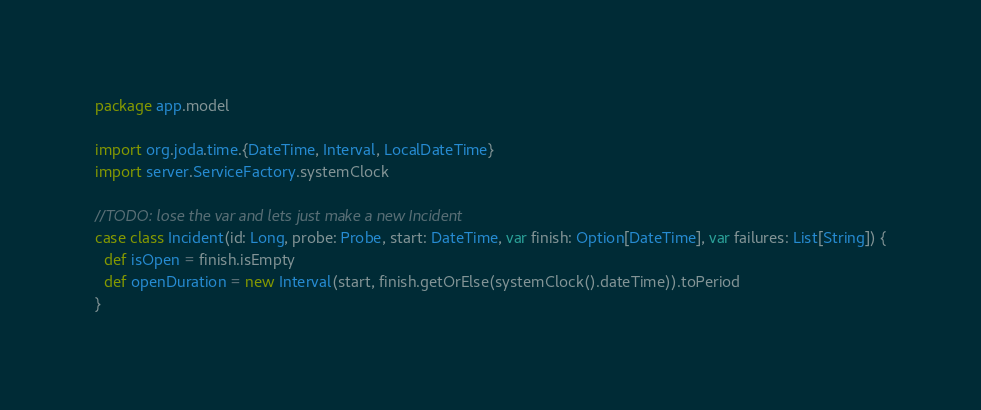<code> <loc_0><loc_0><loc_500><loc_500><_Scala_>package app.model

import org.joda.time.{DateTime, Interval, LocalDateTime}
import server.ServiceFactory.systemClock

//TODO: lose the var and lets just make a new Incident
case class Incident(id: Long, probe: Probe, start: DateTime, var finish: Option[DateTime], var failures: List[String]) {
  def isOpen = finish.isEmpty
  def openDuration = new Interval(start, finish.getOrElse(systemClock().dateTime)).toPeriod
}
</code> 